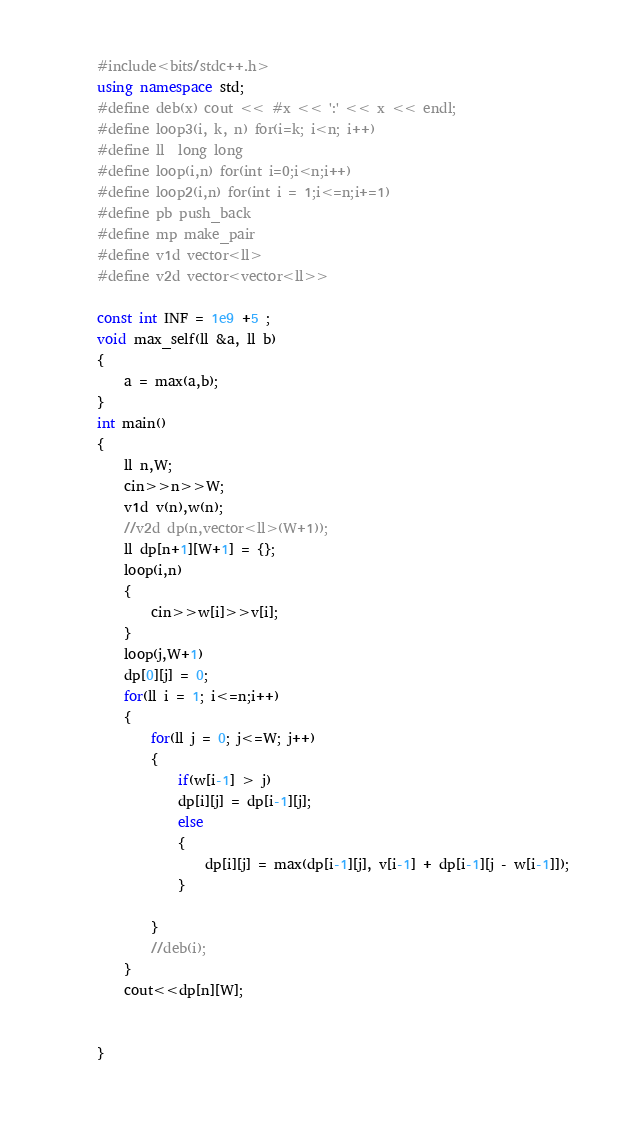Convert code to text. <code><loc_0><loc_0><loc_500><loc_500><_C++_>#include<bits/stdc++.h>
using namespace std;
#define deb(x) cout << #x << ':' << x << endl;
#define loop3(i, k, n) for(i=k; i<n; i++)
#define ll  long long 
#define loop(i,n) for(int i=0;i<n;i++)
#define loop2(i,n) for(int i = 1;i<=n;i+=1)
#define pb push_back
#define mp make_pair
#define v1d vector<ll> 
#define v2d vector<vector<ll>>

const int INF = 1e9 +5 ;
void max_self(ll &a, ll b)
{
    a = max(a,b);
}
int main()
{
    ll n,W;
    cin>>n>>W;
    v1d v(n),w(n);
    //v2d dp(n,vector<ll>(W+1));
    ll dp[n+1][W+1] = {};
    loop(i,n)
    {
        cin>>w[i]>>v[i];
    }
    loop(j,W+1)
    dp[0][j] = 0;
    for(ll i = 1; i<=n;i++)
    {
        for(ll j = 0; j<=W; j++)
        {
            if(w[i-1] > j)
            dp[i][j] = dp[i-1][j];
            else
            {
                dp[i][j] = max(dp[i-1][j], v[i-1] + dp[i-1][j - w[i-1]]);
            }
            
        }
        //deb(i);
    }
    cout<<dp[n][W];

    
}</code> 